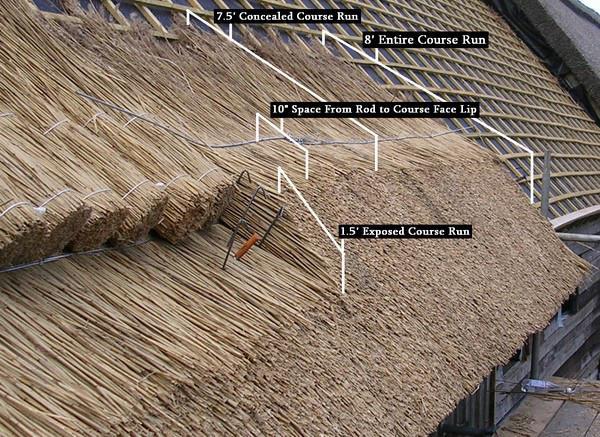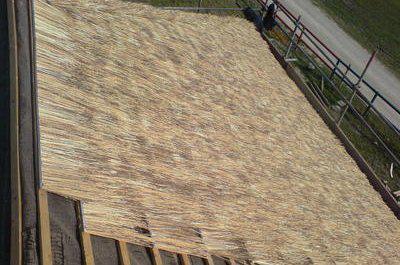The first image is the image on the left, the second image is the image on the right. Examine the images to the left and right. Is the description "An image includes several roll-shaped tied bundles of thatch laying on an unfinished roof without a ladder propped against it." accurate? Answer yes or no. Yes. The first image is the image on the left, the second image is the image on the right. Considering the images on both sides, is "At least one ladder is touching the thatch." valid? Answer yes or no. No. 